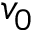Convert formula to latex. <formula><loc_0><loc_0><loc_500><loc_500>v _ { 0 }</formula> 